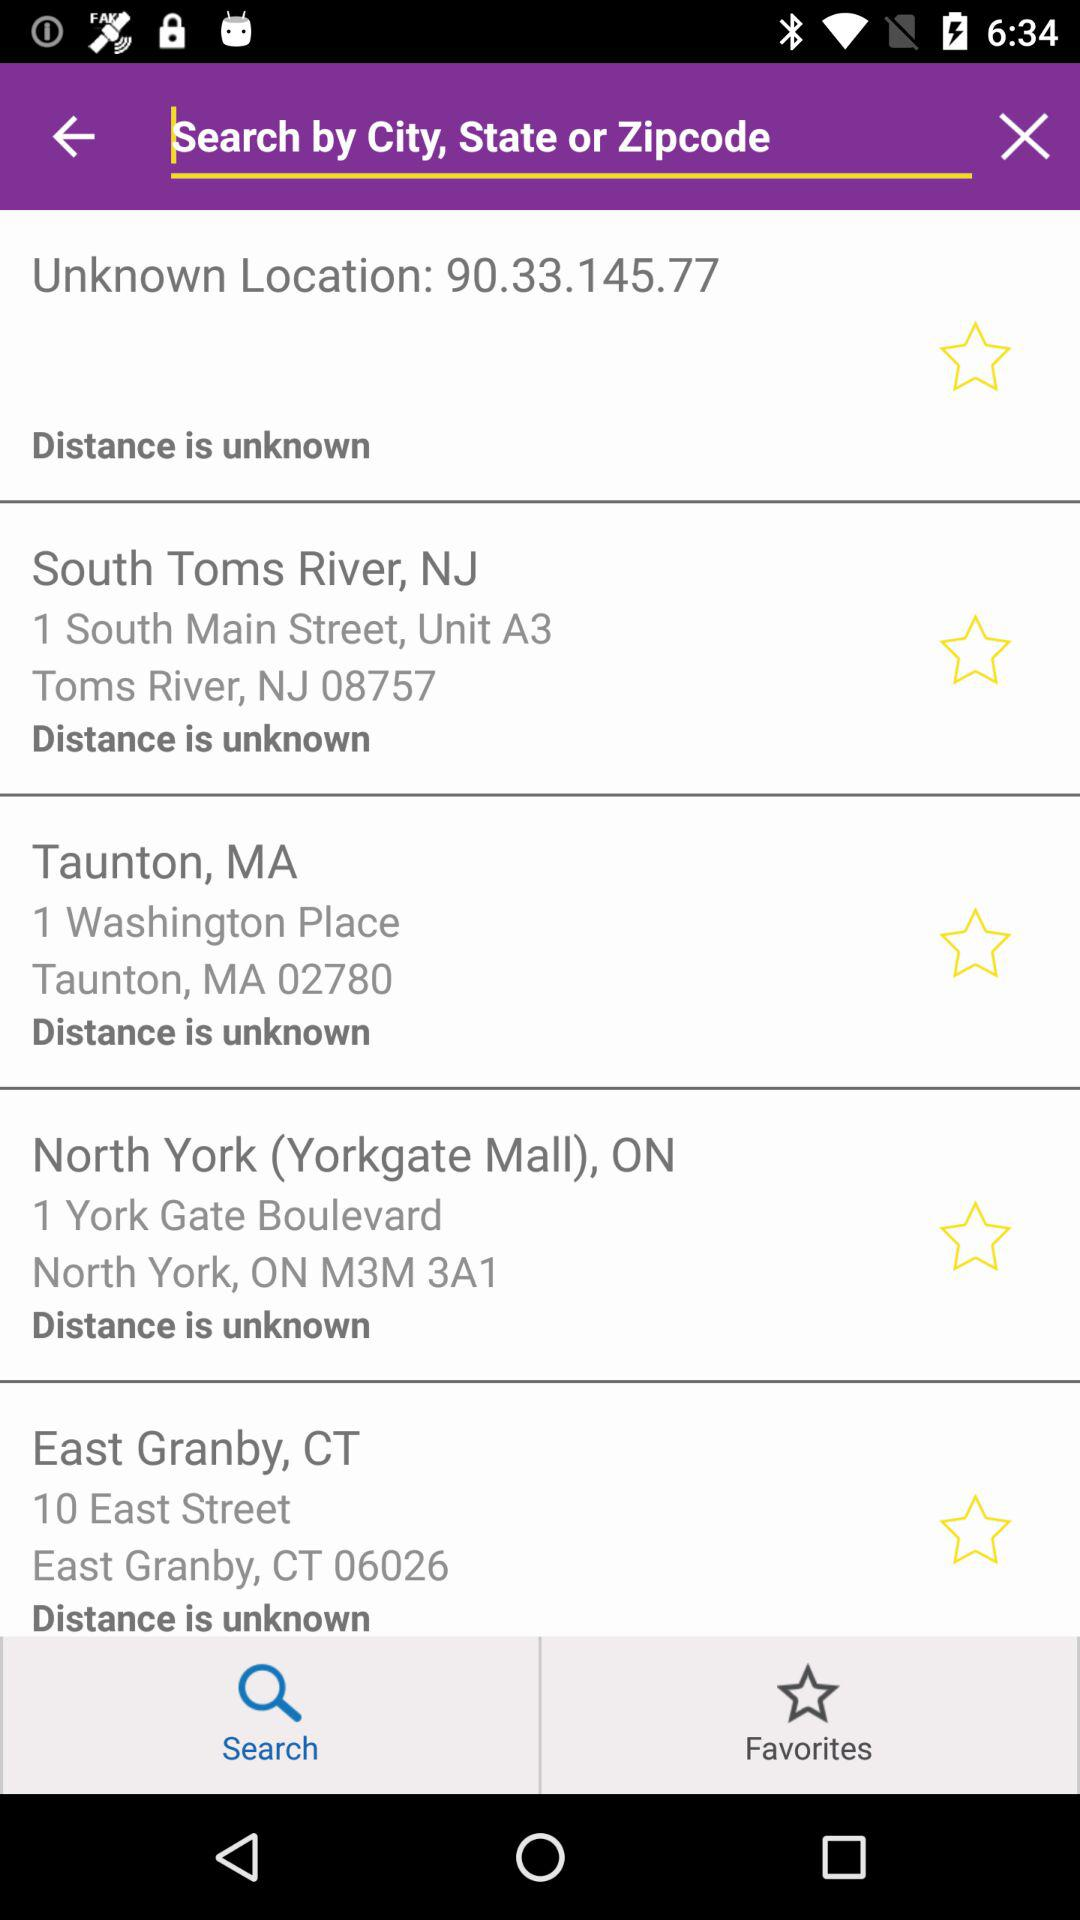What is the address of "Yorkgate Mall"? The address of "Yorkgate Mall" is 1 York Gate Boulevard, North York, ON M3M 3A1. 